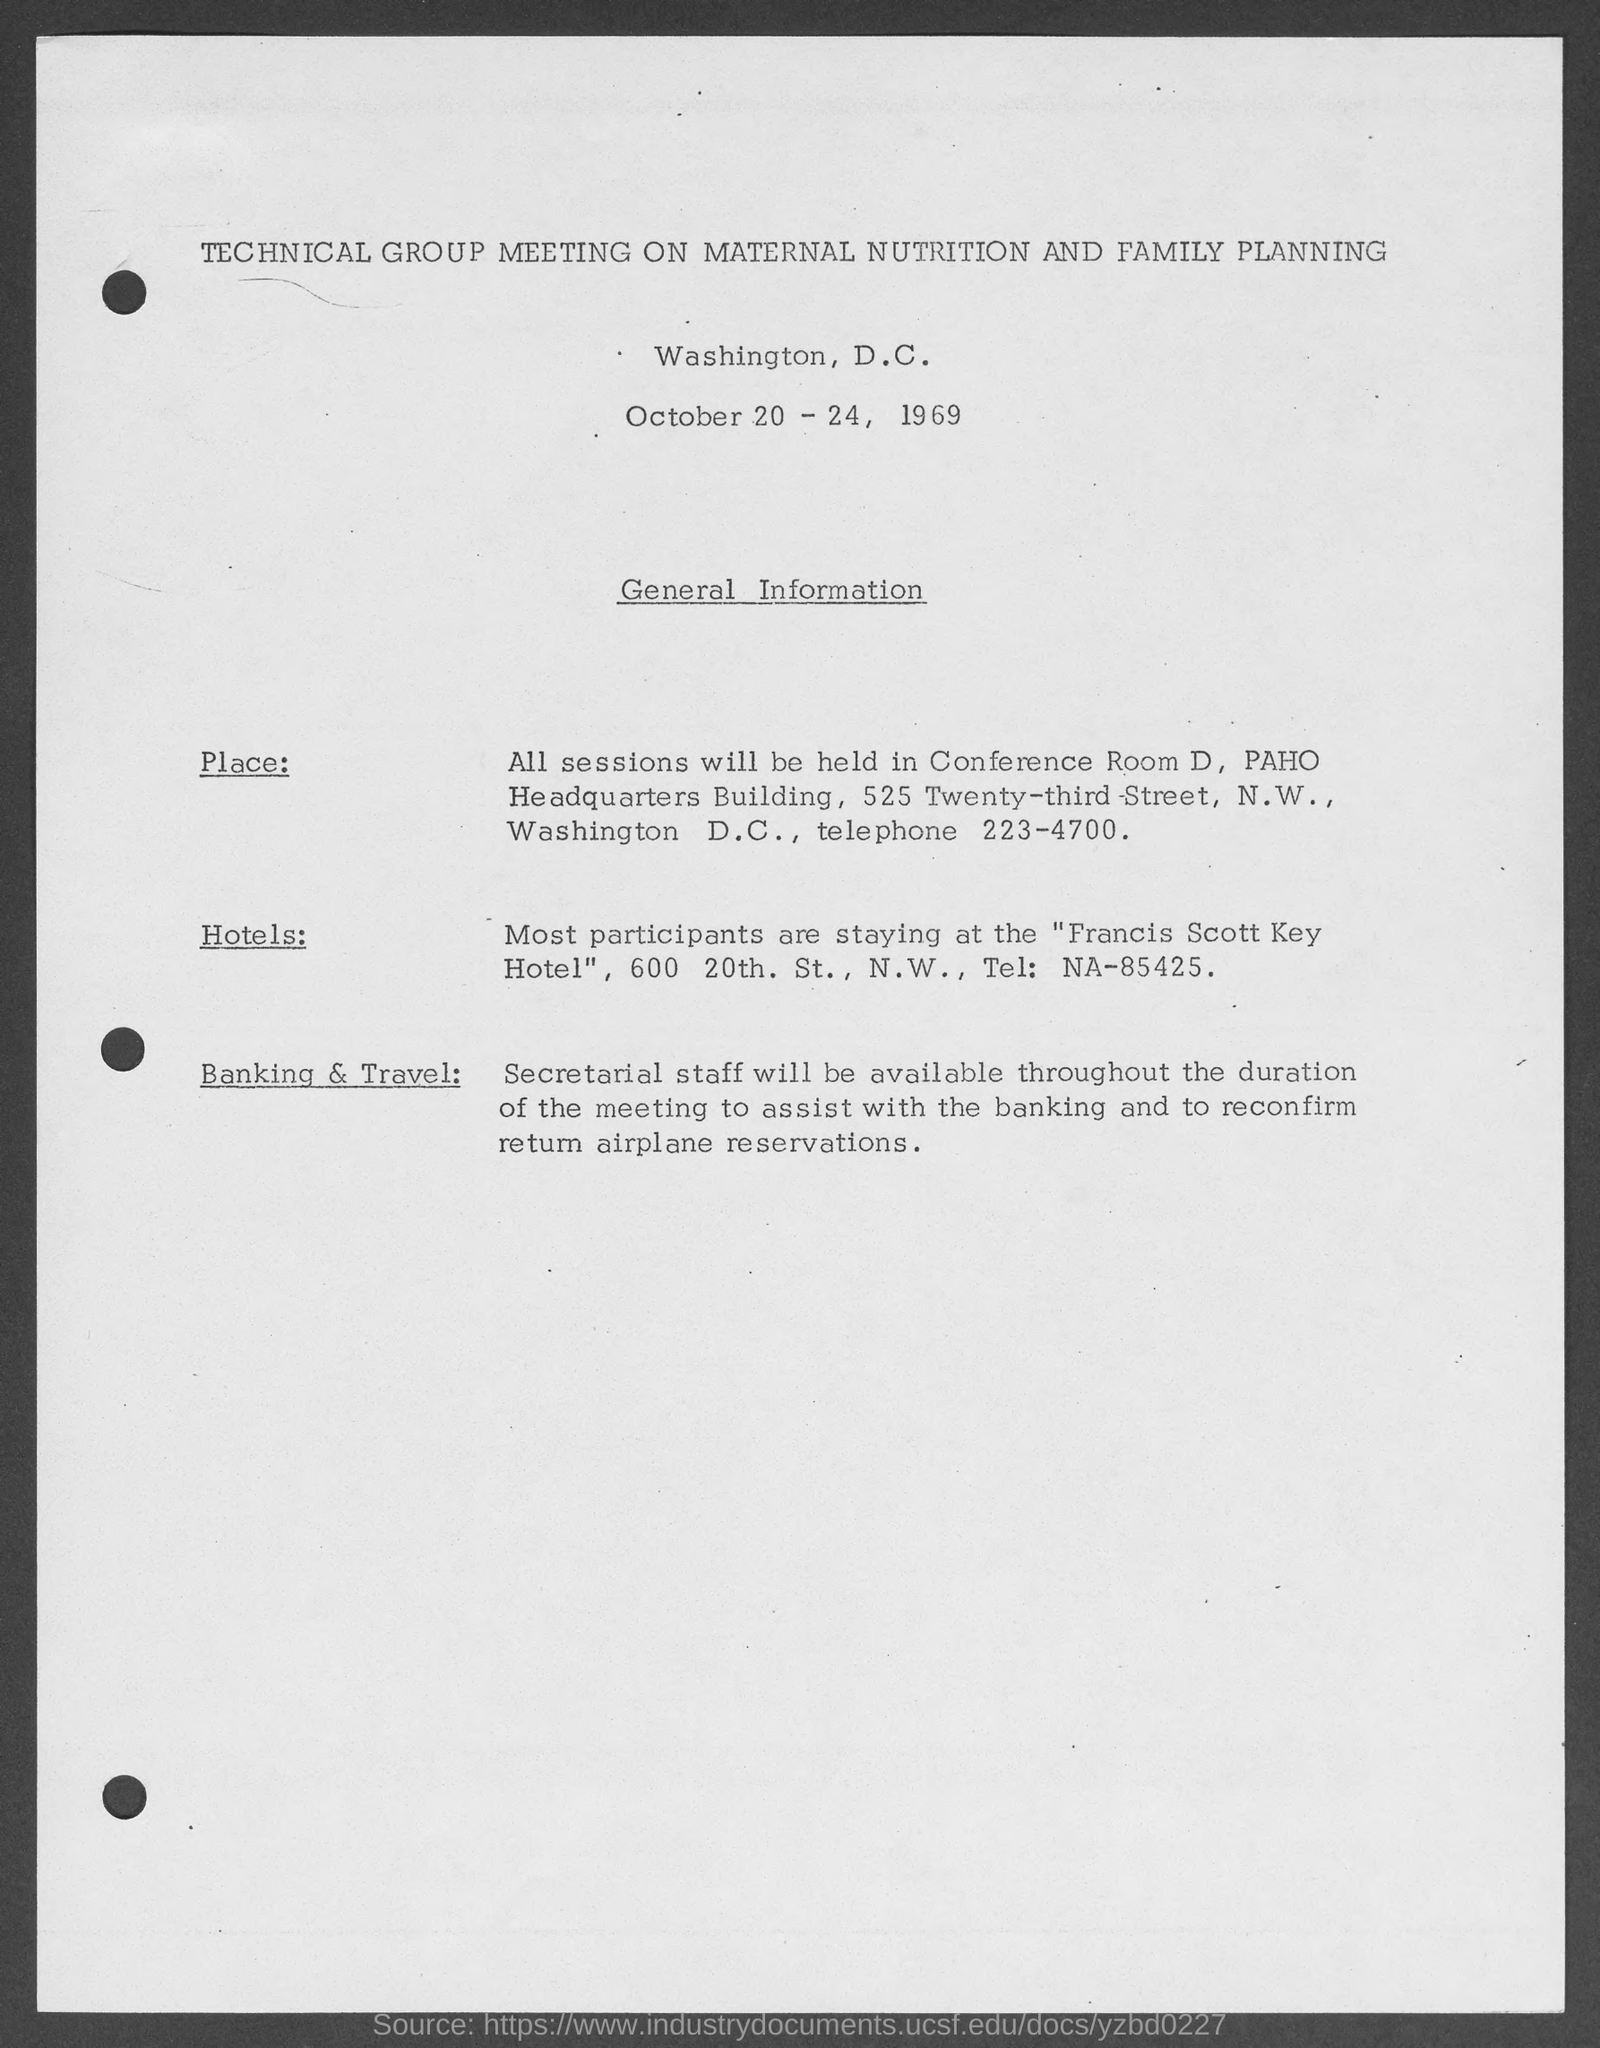When is the technical group meeting on maternal nutrition and family planning scheduled?
Provide a succinct answer. October 20 - 24, 1969. In which city, the technical group meeting on maternal nutrition and family planning is held?
Your answer should be compact. Washington, d.c. Who will be available throughout the duration of the meeting to assist with the banking and to reconfirm return airplane reservations?
Your answer should be compact. Secretarial staff. 